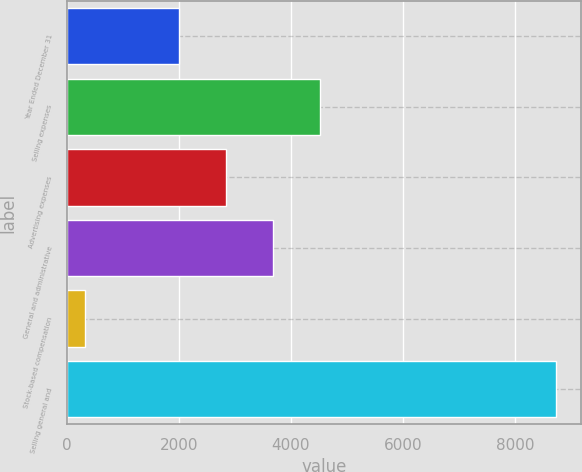Convert chart to OTSL. <chart><loc_0><loc_0><loc_500><loc_500><bar_chart><fcel>Year Ended December 31<fcel>Selling expenses<fcel>Advertising expenses<fcel>General and administrative<fcel>Stock-based compensation<fcel>Selling general and<nl><fcel>2005<fcel>4529.5<fcel>2846.5<fcel>3688<fcel>324<fcel>8739<nl></chart> 